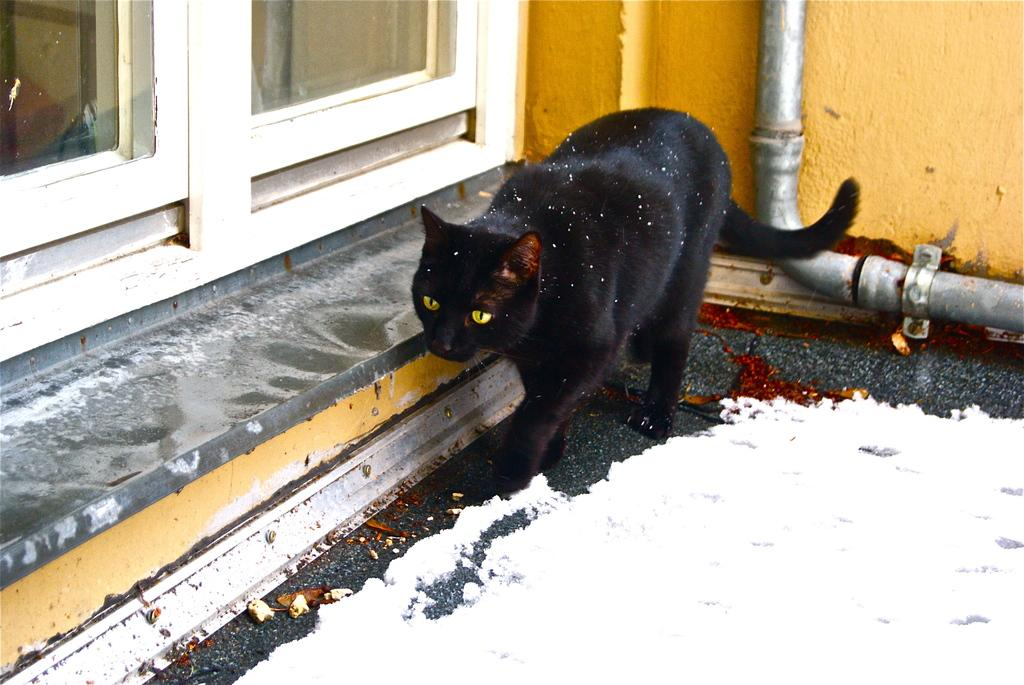What animal can be seen in the image? There is a cat in the image. What is the cat doing in the image? The cat is moving on the floor. What type of weather is suggested by the presence of snow in the image? The presence of snow suggests cold weather. What can be seen in the background of the image? There is a wall in the background of the image. What type of gate can be seen in the image? There is no gate present in the image. What kind of patch is visible on the cat's fur in the image? There is no patch visible on the cat's fur in the image. 